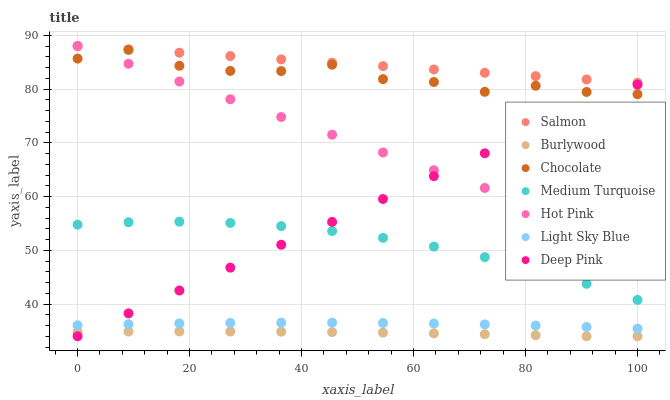Does Burlywood have the minimum area under the curve?
Answer yes or no. Yes. Does Salmon have the maximum area under the curve?
Answer yes or no. Yes. Does Hot Pink have the minimum area under the curve?
Answer yes or no. No. Does Hot Pink have the maximum area under the curve?
Answer yes or no. No. Is Deep Pink the smoothest?
Answer yes or no. Yes. Is Chocolate the roughest?
Answer yes or no. Yes. Is Burlywood the smoothest?
Answer yes or no. No. Is Burlywood the roughest?
Answer yes or no. No. Does Deep Pink have the lowest value?
Answer yes or no. Yes. Does Hot Pink have the lowest value?
Answer yes or no. No. Does Salmon have the highest value?
Answer yes or no. Yes. Does Burlywood have the highest value?
Answer yes or no. No. Is Light Sky Blue less than Chocolate?
Answer yes or no. Yes. Is Salmon greater than Chocolate?
Answer yes or no. Yes. Does Hot Pink intersect Deep Pink?
Answer yes or no. Yes. Is Hot Pink less than Deep Pink?
Answer yes or no. No. Is Hot Pink greater than Deep Pink?
Answer yes or no. No. Does Light Sky Blue intersect Chocolate?
Answer yes or no. No. 